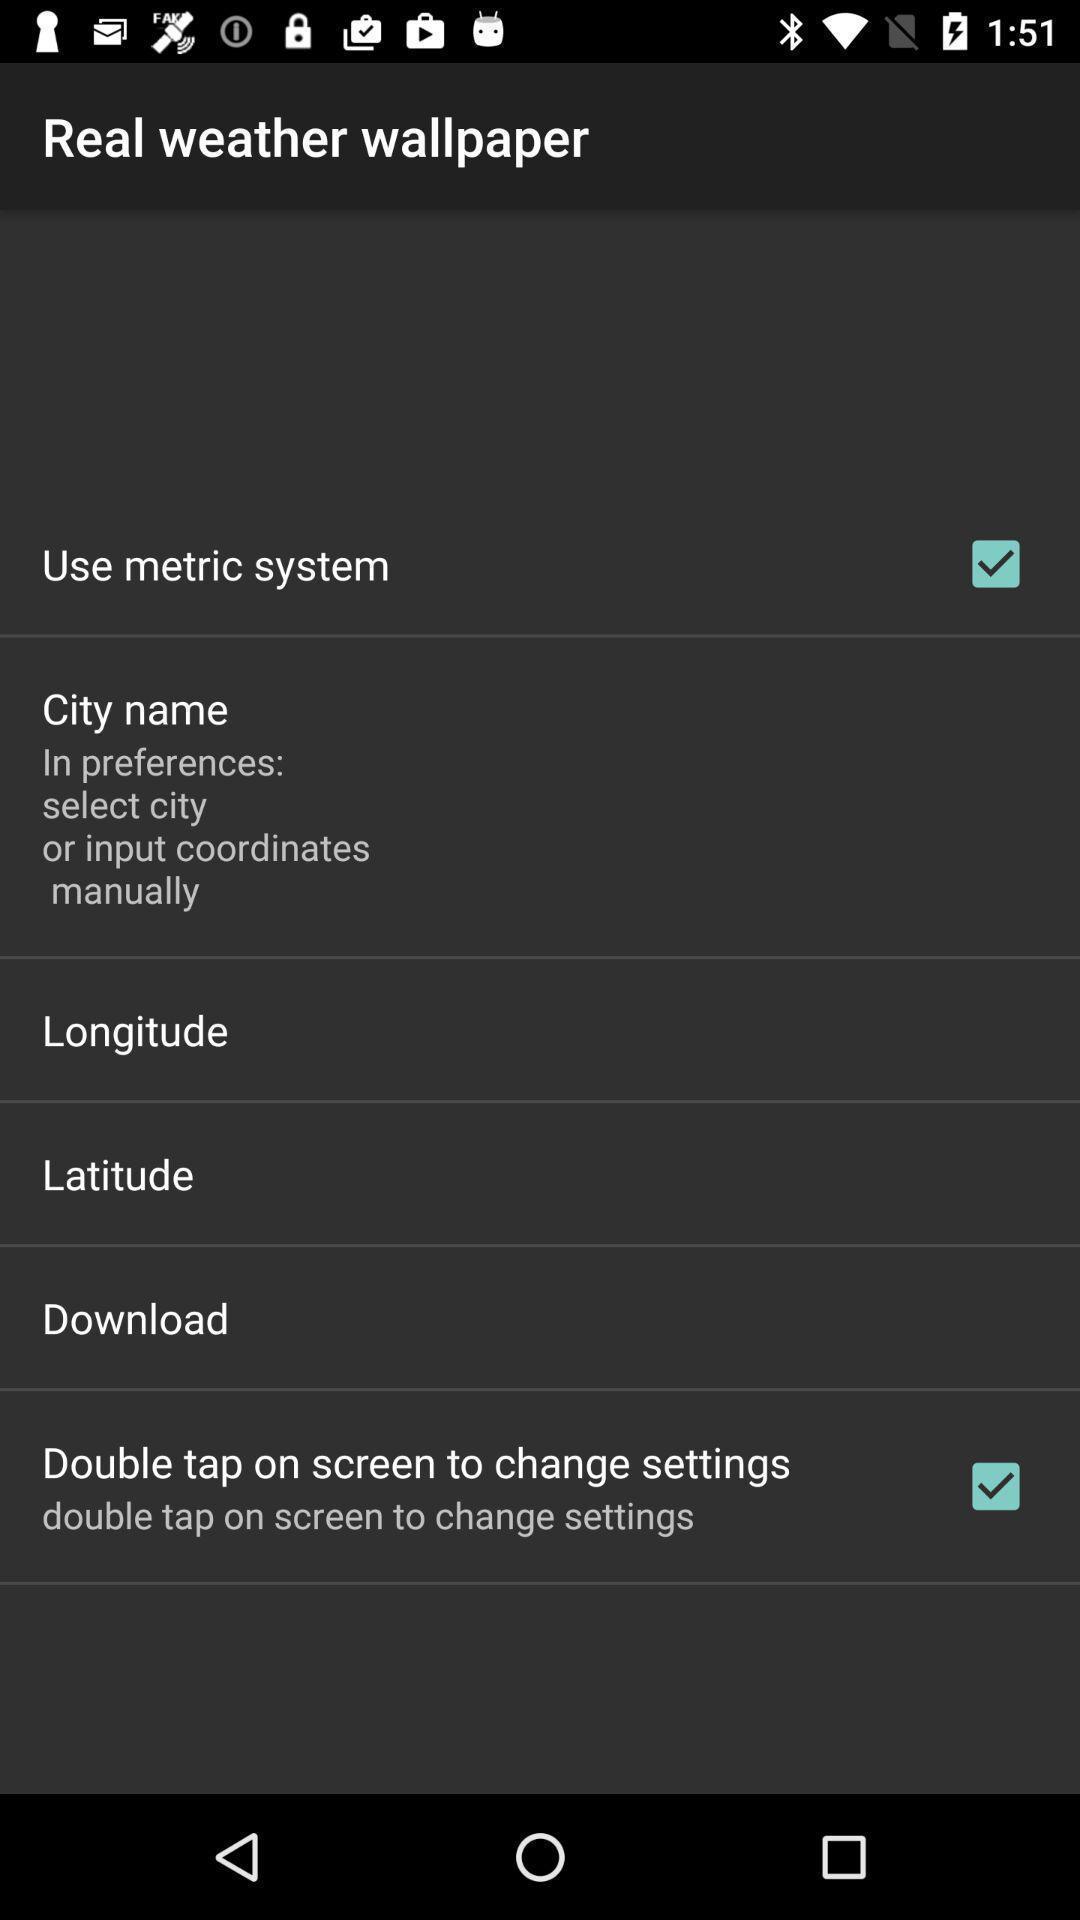Describe the visual elements of this screenshot. Wallpaper settings page. 